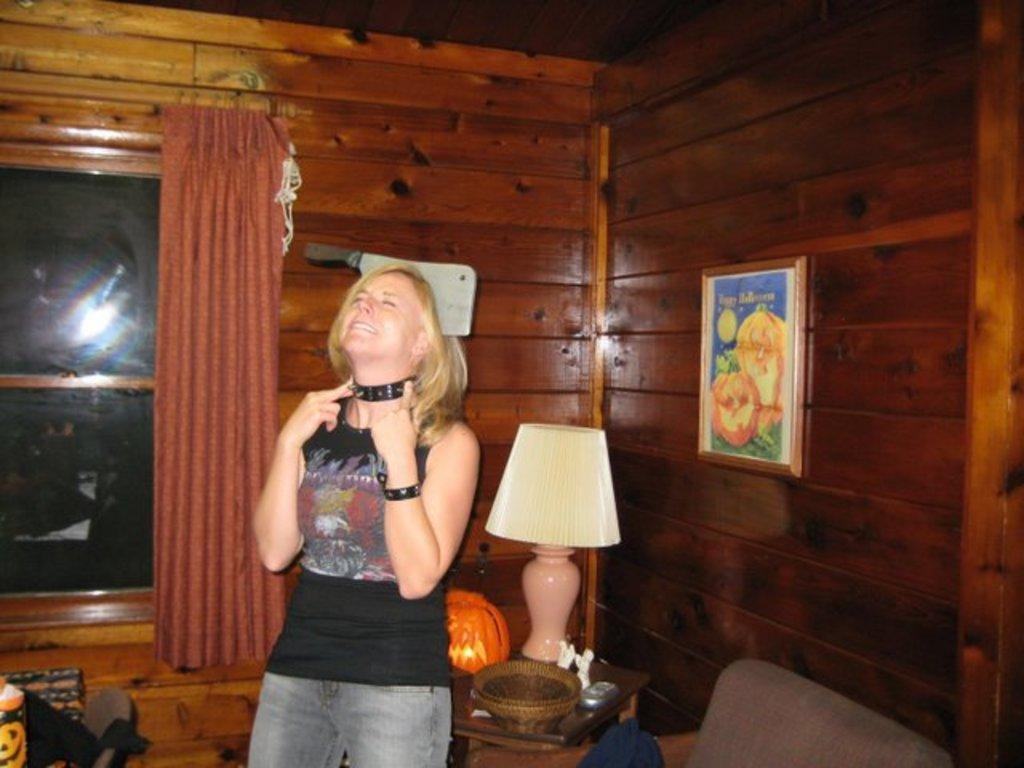Who is present in the image? There is a woman in the image. What is the woman doing in the image? The woman is standing. What is the woman wearing in the image? The woman is wearing a black t-shirt. What can be seen in the background of the image? There is a window and a curtain associated with the window in the image. What type of watch is the woman wearing in the image? There is no watch visible in the image; the woman is wearing a black t-shirt. What kind of pies can be seen on the table in the image? There is no table or pies present in the image; it features a woman standing and wearing a black t-shirt. 